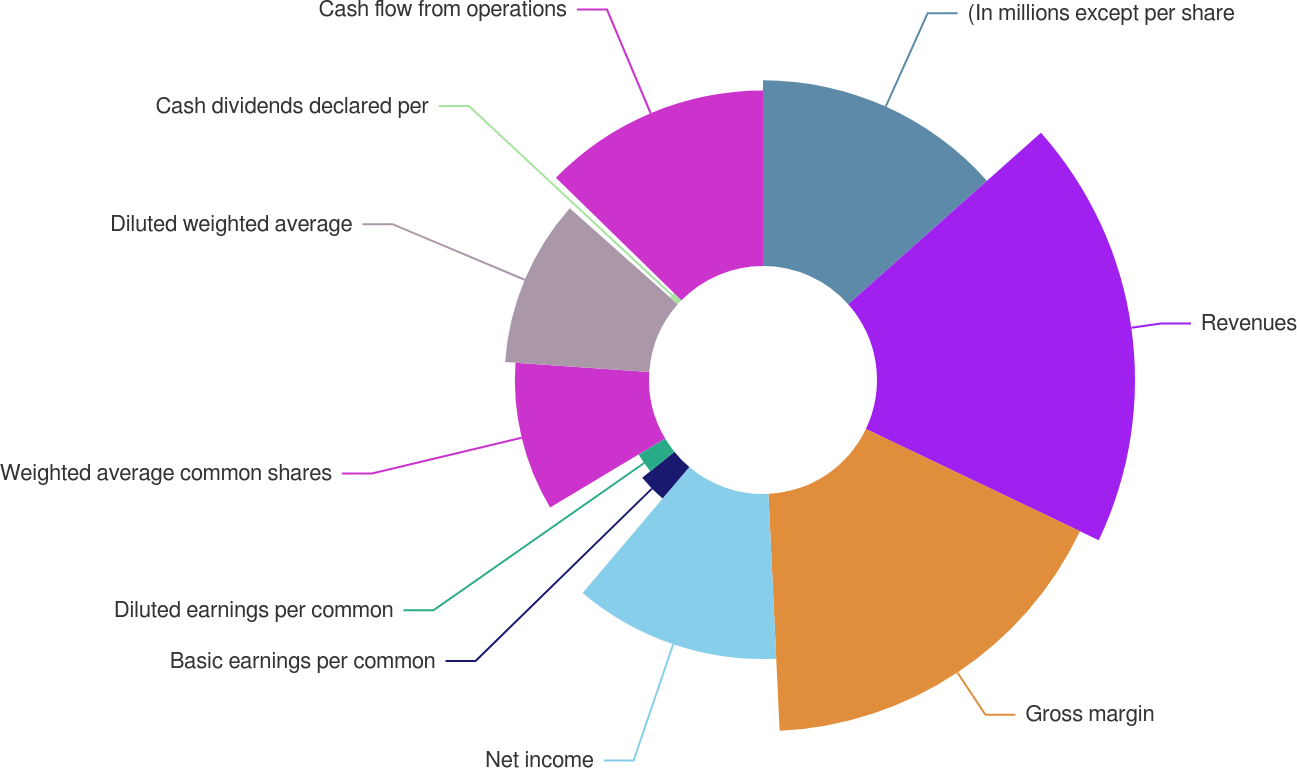Convert chart. <chart><loc_0><loc_0><loc_500><loc_500><pie_chart><fcel>(In millions except per share<fcel>Revenues<fcel>Gross margin<fcel>Net income<fcel>Basic earnings per common<fcel>Diluted earnings per common<fcel>Weighted average common shares<fcel>Diluted weighted average<fcel>Cash dividends declared per<fcel>Cash flow from operations<nl><fcel>13.43%<fcel>18.66%<fcel>17.16%<fcel>11.94%<fcel>2.99%<fcel>2.24%<fcel>9.7%<fcel>10.45%<fcel>0.75%<fcel>12.69%<nl></chart> 